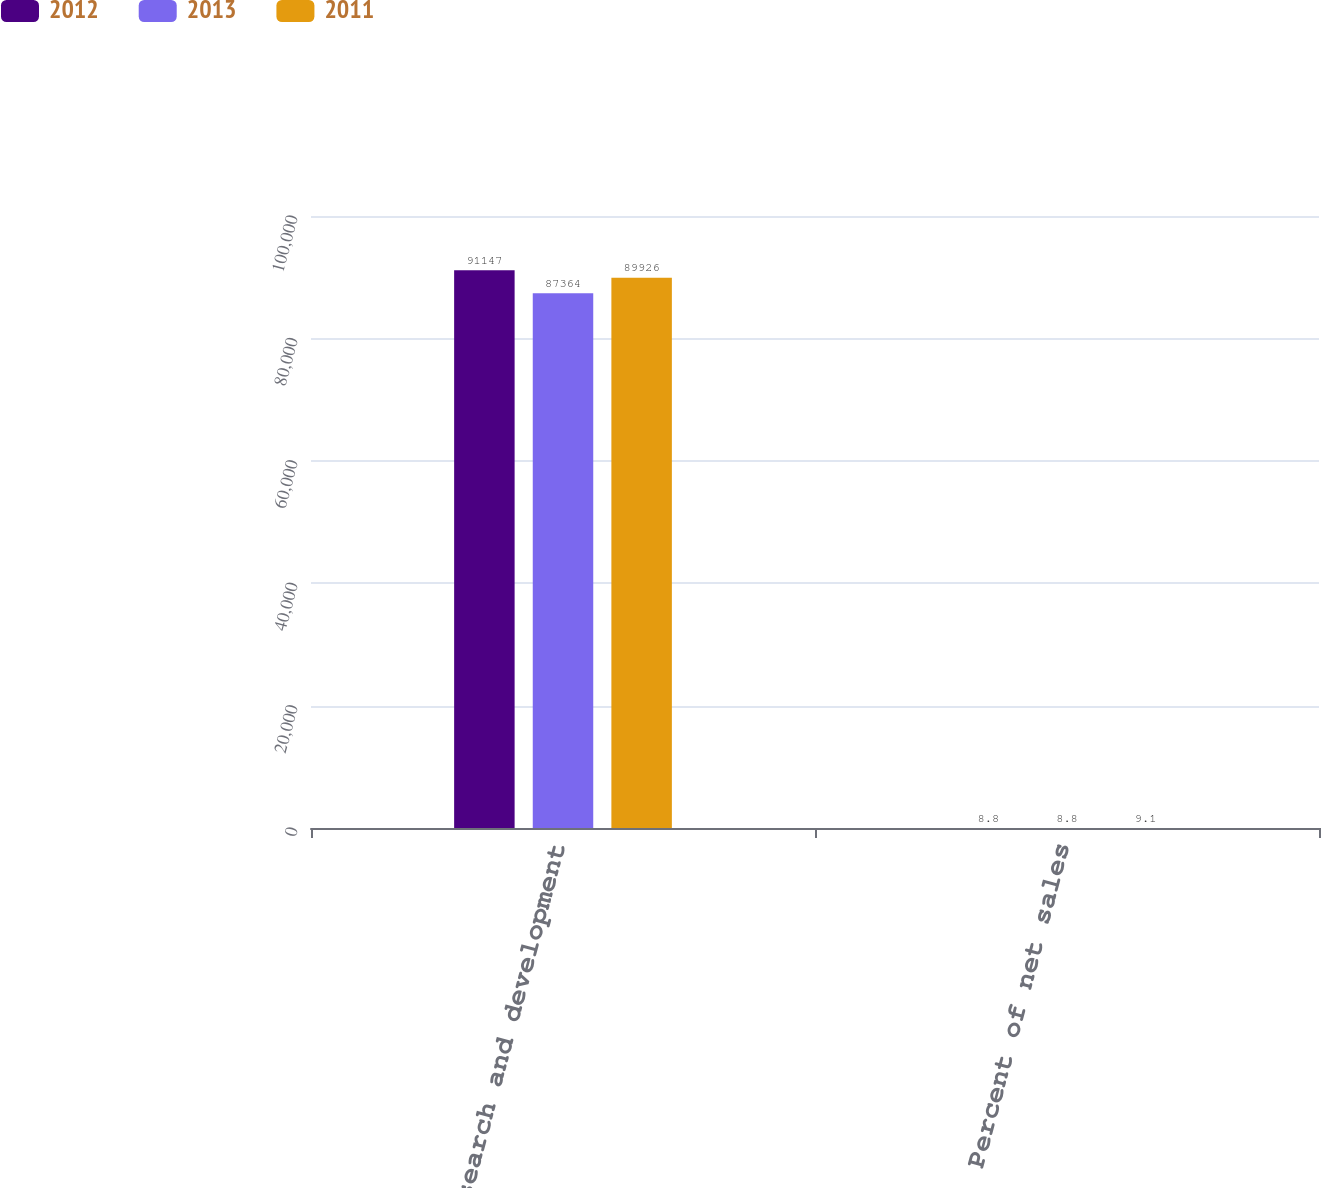Convert chart to OTSL. <chart><loc_0><loc_0><loc_500><loc_500><stacked_bar_chart><ecel><fcel>Research and development<fcel>Percent of net sales<nl><fcel>2012<fcel>91147<fcel>8.8<nl><fcel>2013<fcel>87364<fcel>8.8<nl><fcel>2011<fcel>89926<fcel>9.1<nl></chart> 